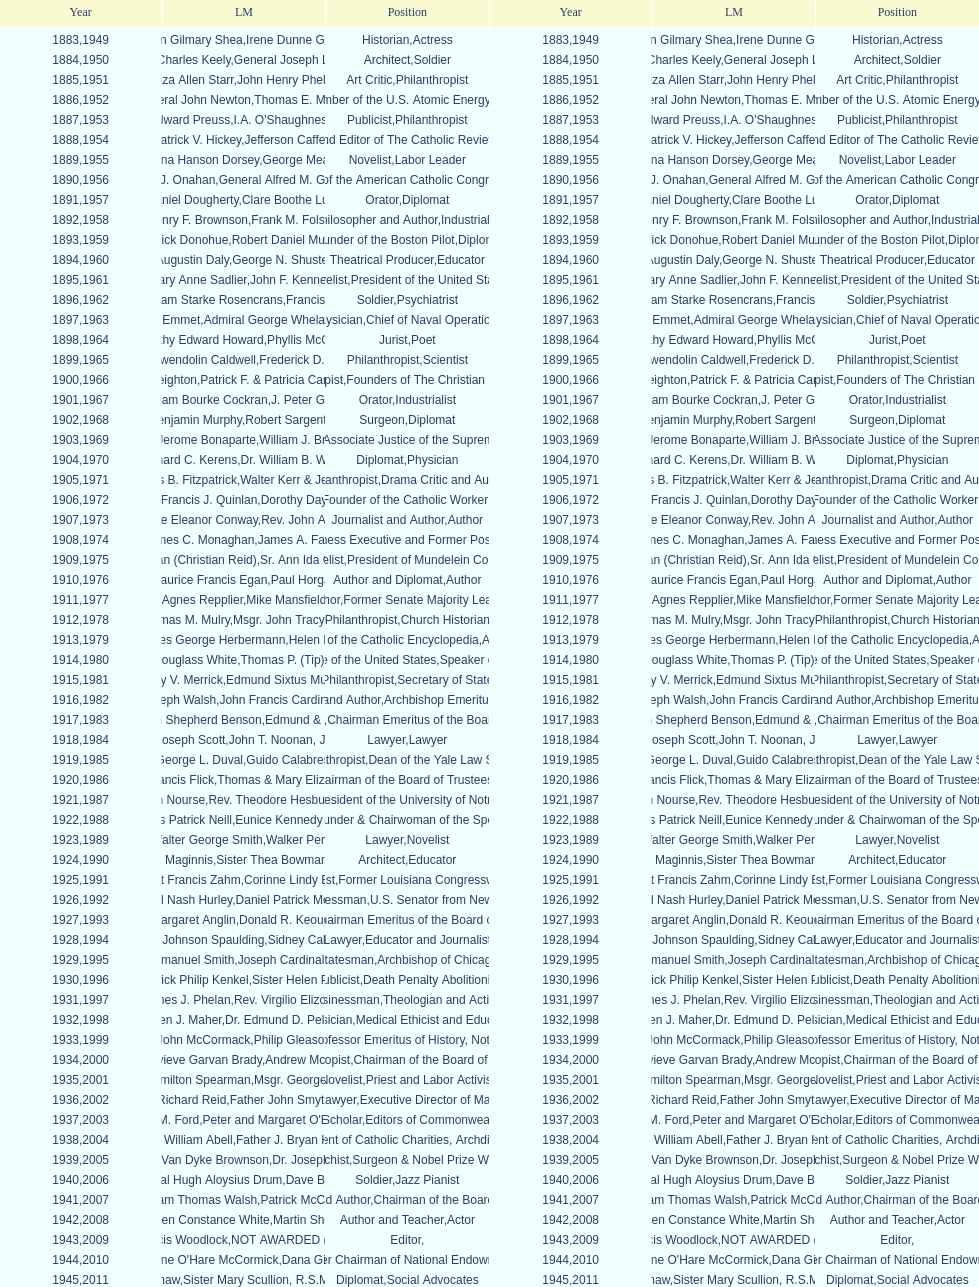What are the total number of times soldier is listed as the position on this chart? 4. 